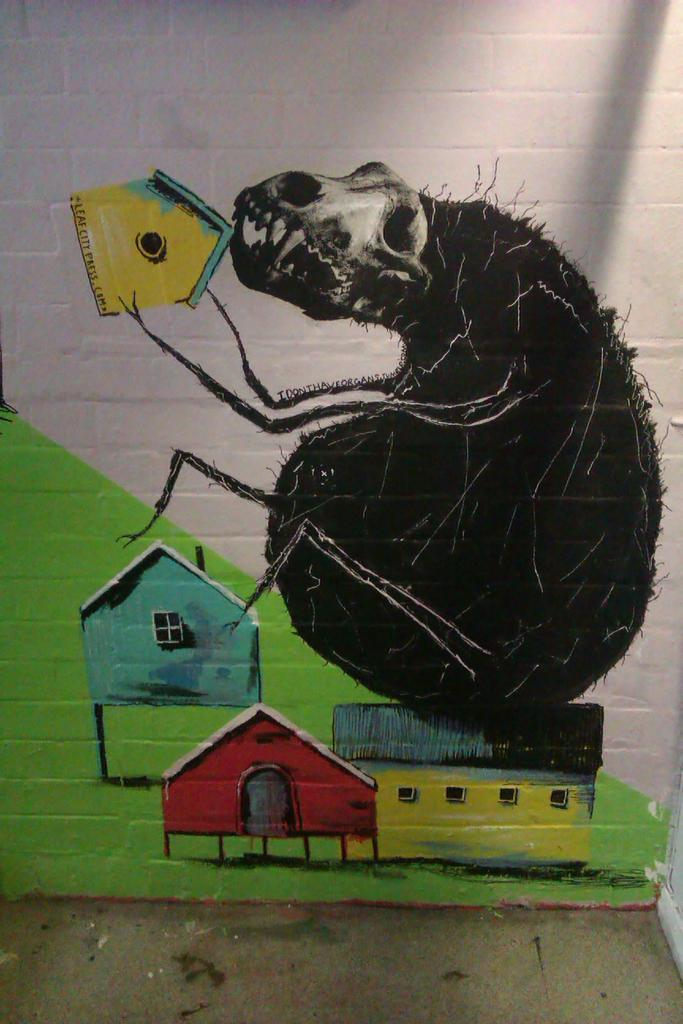Where was the image taken? The image is taken indoors. What can be seen on the wall in the image? There is a painting on the wall in the image. What is visible at the bottom of the image? There is a floor visible at the bottom of the image. What type of club is featured in the painting on the wall? There is no club present in the painting on the wall; it is a painting and not a photograph. 